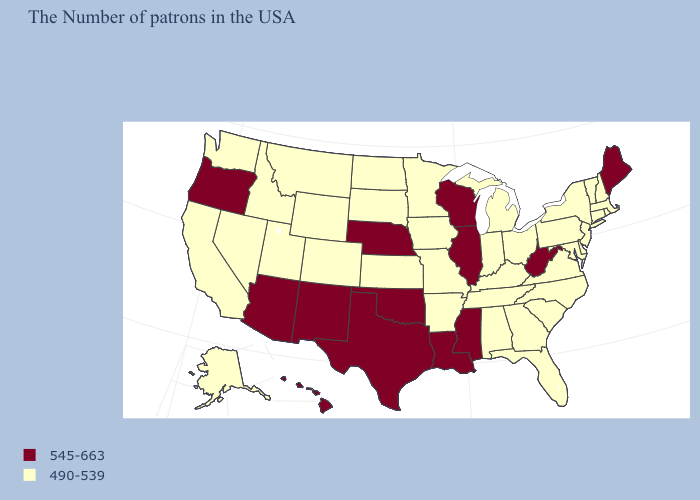Which states have the highest value in the USA?
Give a very brief answer. Maine, West Virginia, Wisconsin, Illinois, Mississippi, Louisiana, Nebraska, Oklahoma, Texas, New Mexico, Arizona, Oregon, Hawaii. Among the states that border Texas , does New Mexico have the lowest value?
Keep it brief. No. Among the states that border Louisiana , which have the lowest value?
Be succinct. Arkansas. What is the value of New Jersey?
Be succinct. 490-539. What is the lowest value in the MidWest?
Answer briefly. 490-539. Does the map have missing data?
Give a very brief answer. No. What is the highest value in the West ?
Concise answer only. 545-663. What is the value of Connecticut?
Be succinct. 490-539. Does Mississippi have the lowest value in the USA?
Write a very short answer. No. What is the value of Louisiana?
Keep it brief. 545-663. What is the highest value in the MidWest ?
Keep it brief. 545-663. What is the value of Connecticut?
Short answer required. 490-539. What is the value of Colorado?
Concise answer only. 490-539. 